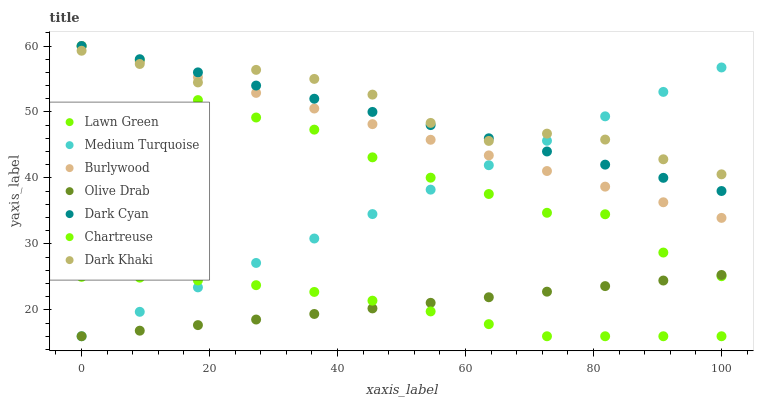Does Chartreuse have the minimum area under the curve?
Answer yes or no. Yes. Does Dark Khaki have the maximum area under the curve?
Answer yes or no. Yes. Does Burlywood have the minimum area under the curve?
Answer yes or no. No. Does Burlywood have the maximum area under the curve?
Answer yes or no. No. Is Olive Drab the smoothest?
Answer yes or no. Yes. Is Lawn Green the roughest?
Answer yes or no. Yes. Is Burlywood the smoothest?
Answer yes or no. No. Is Burlywood the roughest?
Answer yes or no. No. Does Chartreuse have the lowest value?
Answer yes or no. Yes. Does Burlywood have the lowest value?
Answer yes or no. No. Does Dark Cyan have the highest value?
Answer yes or no. Yes. Does Dark Khaki have the highest value?
Answer yes or no. No. Is Olive Drab less than Dark Cyan?
Answer yes or no. Yes. Is Dark Cyan greater than Chartreuse?
Answer yes or no. Yes. Does Dark Khaki intersect Medium Turquoise?
Answer yes or no. Yes. Is Dark Khaki less than Medium Turquoise?
Answer yes or no. No. Is Dark Khaki greater than Medium Turquoise?
Answer yes or no. No. Does Olive Drab intersect Dark Cyan?
Answer yes or no. No. 